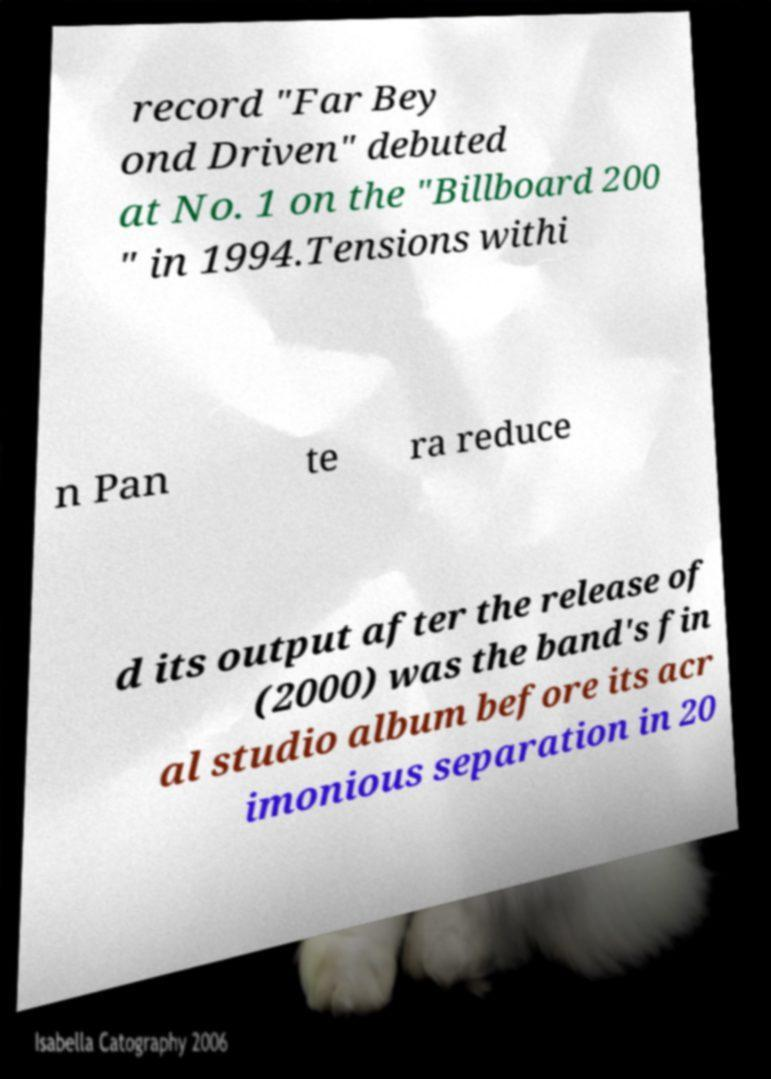Could you assist in decoding the text presented in this image and type it out clearly? record "Far Bey ond Driven" debuted at No. 1 on the "Billboard 200 " in 1994.Tensions withi n Pan te ra reduce d its output after the release of (2000) was the band's fin al studio album before its acr imonious separation in 20 